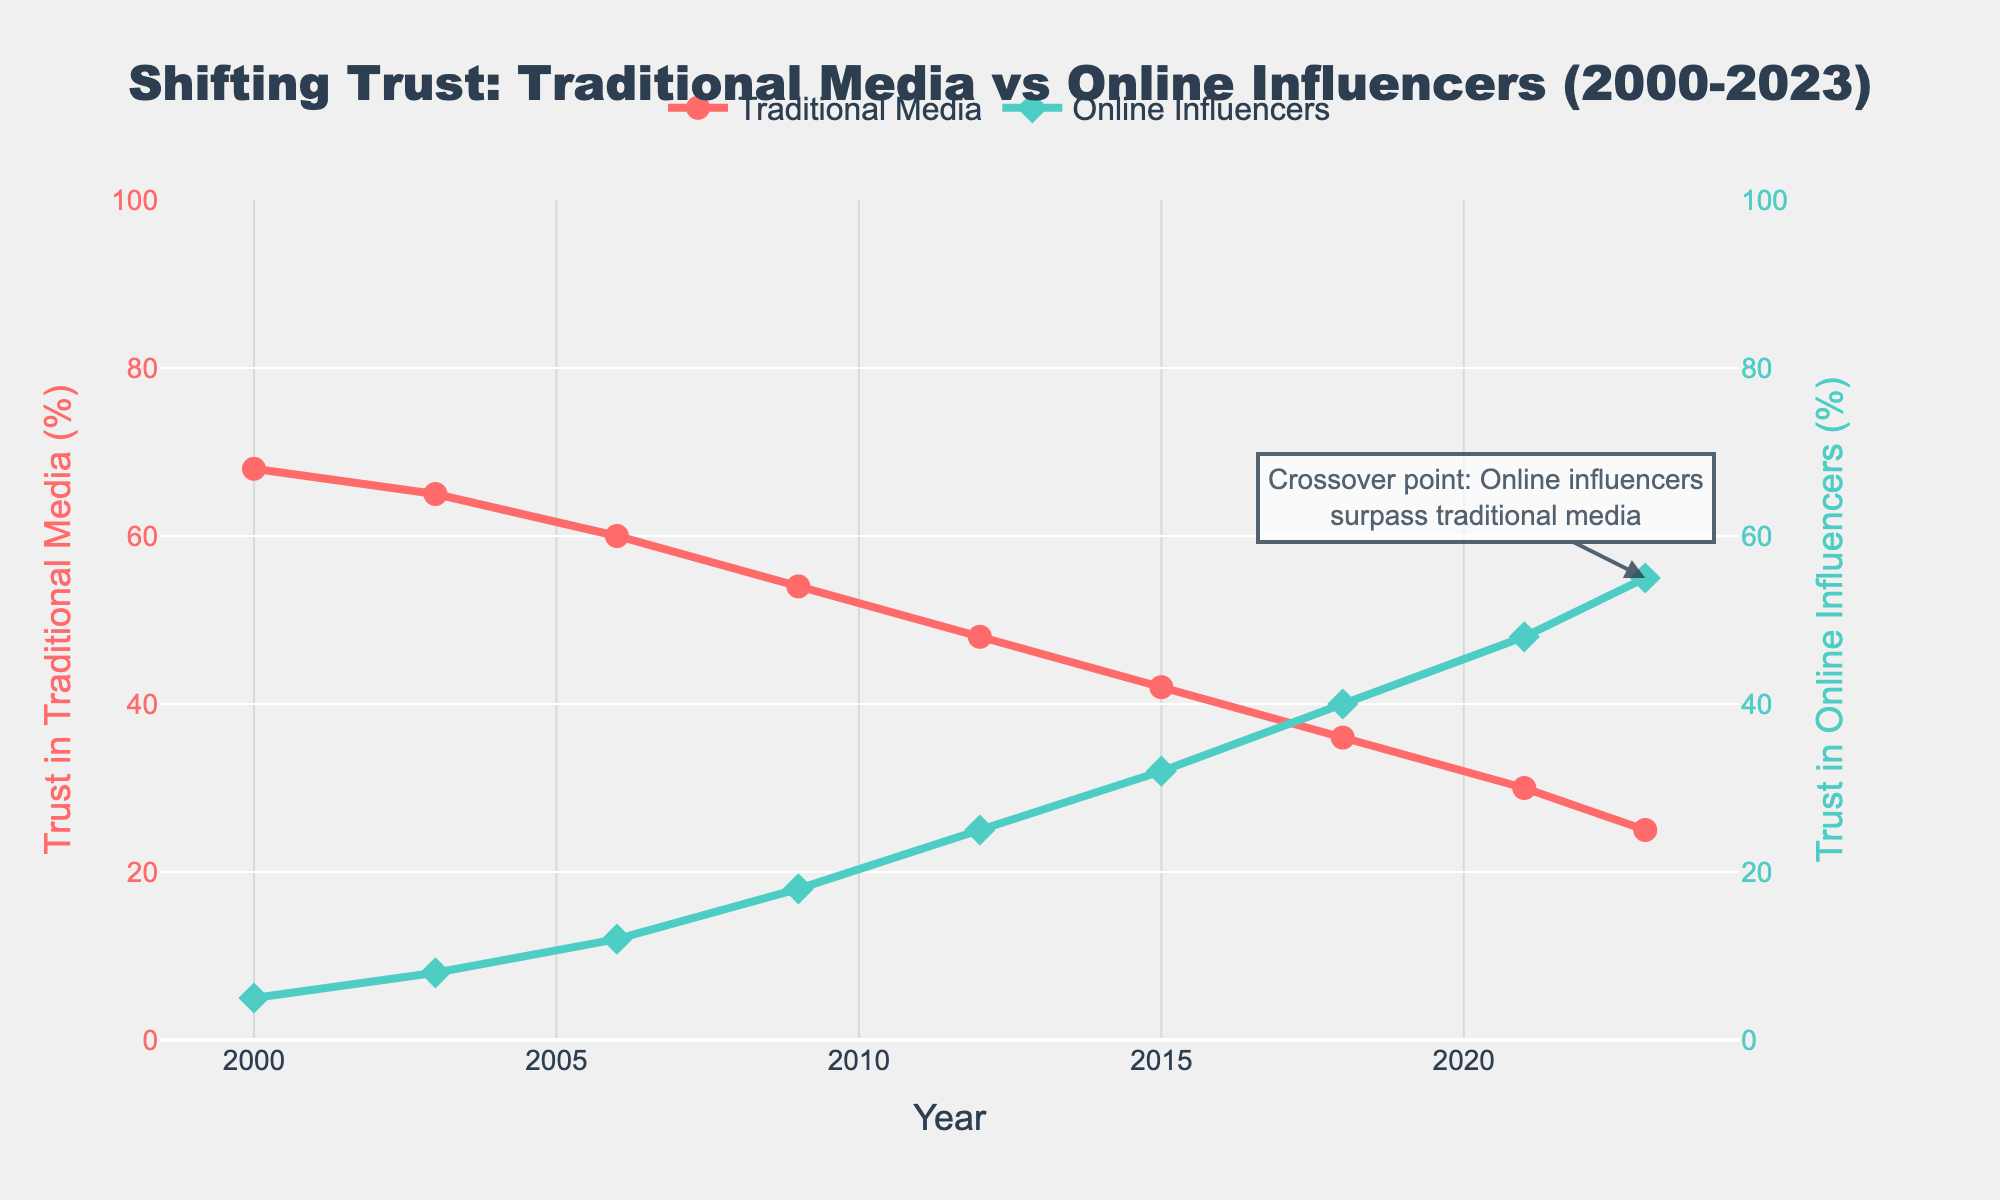What year did trust in online influencers surpass trust in traditional media? In the figure, we see an annotation pointing out that 2023 is the crossover point where trust in online influencers surpasses trust in traditional media.
Answer: 2023 How much did trust in traditional media drop from 2000 to 2023? Trust in traditional media in 2000 was 68%, and in 2023 it was 25%. The drop can be calculated as 68% - 25% = 43%.
Answer: 43% By how many percentage points did trust in online influencers increase from 2000 to 2023? Trust in online influencers was 5% in 2000 and 55% in 2023. The increase can be calculated as 55% - 5% = 50%.
Answer: 50% What are the trust values for traditional media and online influencers in 2015? In the figure, the trust values in 2015 are given as 42% for traditional media and 32% for online influencers.
Answer: 42% and 32% Between which consecutive years did traditional media see the largest drop in trust? We need to look at the differences in trust percentages for each consecutive year and find the largest drop. From 2000 to 2003: 68% - 65% = 3%, 2003 to 2006: 65% - 60% = 5%, 2006 to 2009: 60% - 54% = 6%, 2009 to 2012: 54% - 48% = 6%, 2012 to 2015: 48% - 42% = 6%, 2015 to 2018: 42% - 36% = 6%, 2018 to 2021: 36% - 30% = 6%, 2021 to 2023: 30% - 25% = 5%. So the largest drop was 6% which occurred between three pairs of years: 2006-2009, 2009-2012, 2012-2015, 2015-2018.
Answer: 2006-2009, 2009-2012, 2012-2015, 2015-2018 How many times in the period from 2000 to 2023 did trust in online influencers increase by more than 5 percentage points in consecutive years? We need to calculate the increase in trust for each consecutive year. 2000 to 2003: 8% - 5% = 3%, 2003 to 2006: 12% - 8% = 4%, 2006 to 2009: 18% - 12% = 6%, 2009 to 2012: 25% - 18% = 7%, 2012 to 2015: 32% - 25% = 7%, 2015 to 2018: 40% - 32% = 8%, 2018 to 2021: 48% - 40% = 8%, 2021 to 2023: 55% - 48% = 7%. So the count of increases greater than 5 points is 5 (2006-2009, 2009-2012, 2012-2015, 2015-2018, 2018-2021, 2021-2023).
Answer: 5 What is the average trust level in traditional media from 2000 to 2023? Sum the trust levels for traditional media from 2000, 2003, 2006, 2009, 2012, 2015, 2018, 2021, and 2023, then divide by the number of data points. (68+65+60+54+48+42+36+30+25) / 9 = 428 / 9 = 47.56%.
Answer: 47.56% Which year saw the highest trust in traditional media? By examining the figure, we see that the highest trust level in traditional media was in 2000 at 68%.
Answer: 2000 